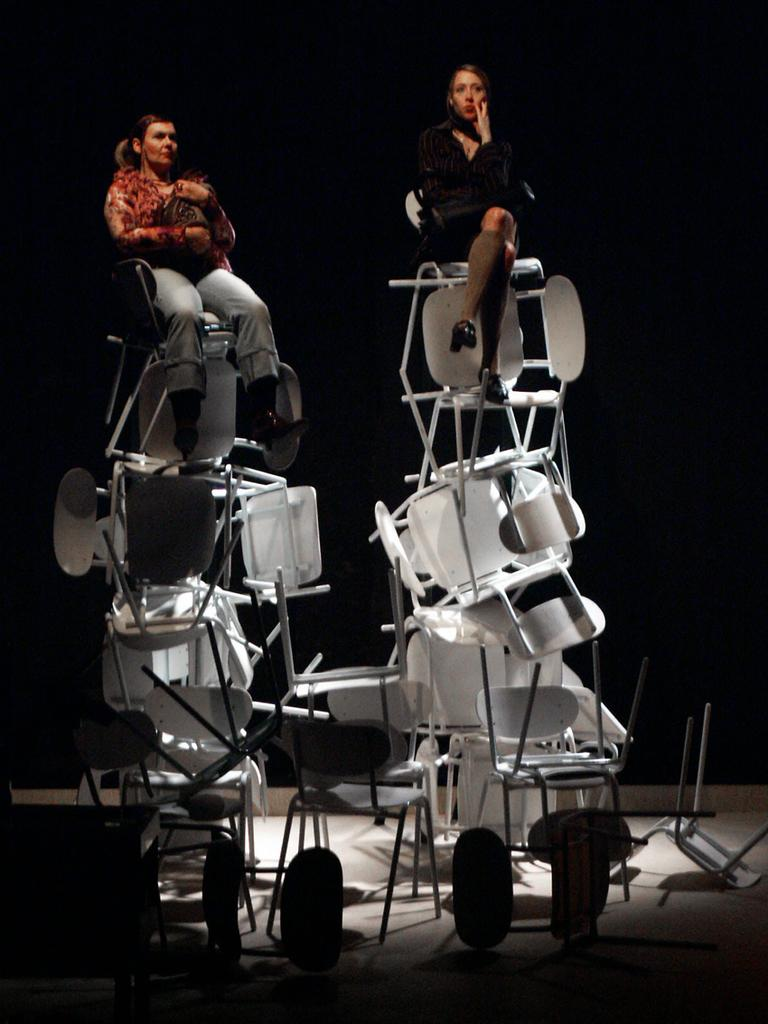How many women are in the image? There are two women in the image. What are the women doing in the image? The women are sitting on top of many chairs. Can you describe the clothing of the woman on the left? The woman on the left is wearing a pair of jeans, a shirt, and shoes. What color is the dress worn by the woman on the right? The woman on the right is wearing a black-colored dress. What type of polish is the woman on the left applying to her nails in the image? There is no indication in the image that the woman on the left is applying any polish to her nails. Can you tell me how the engine of the chair works in the image? The image does not show any chairs with engines, as the women are sitting on top of many chairs. 